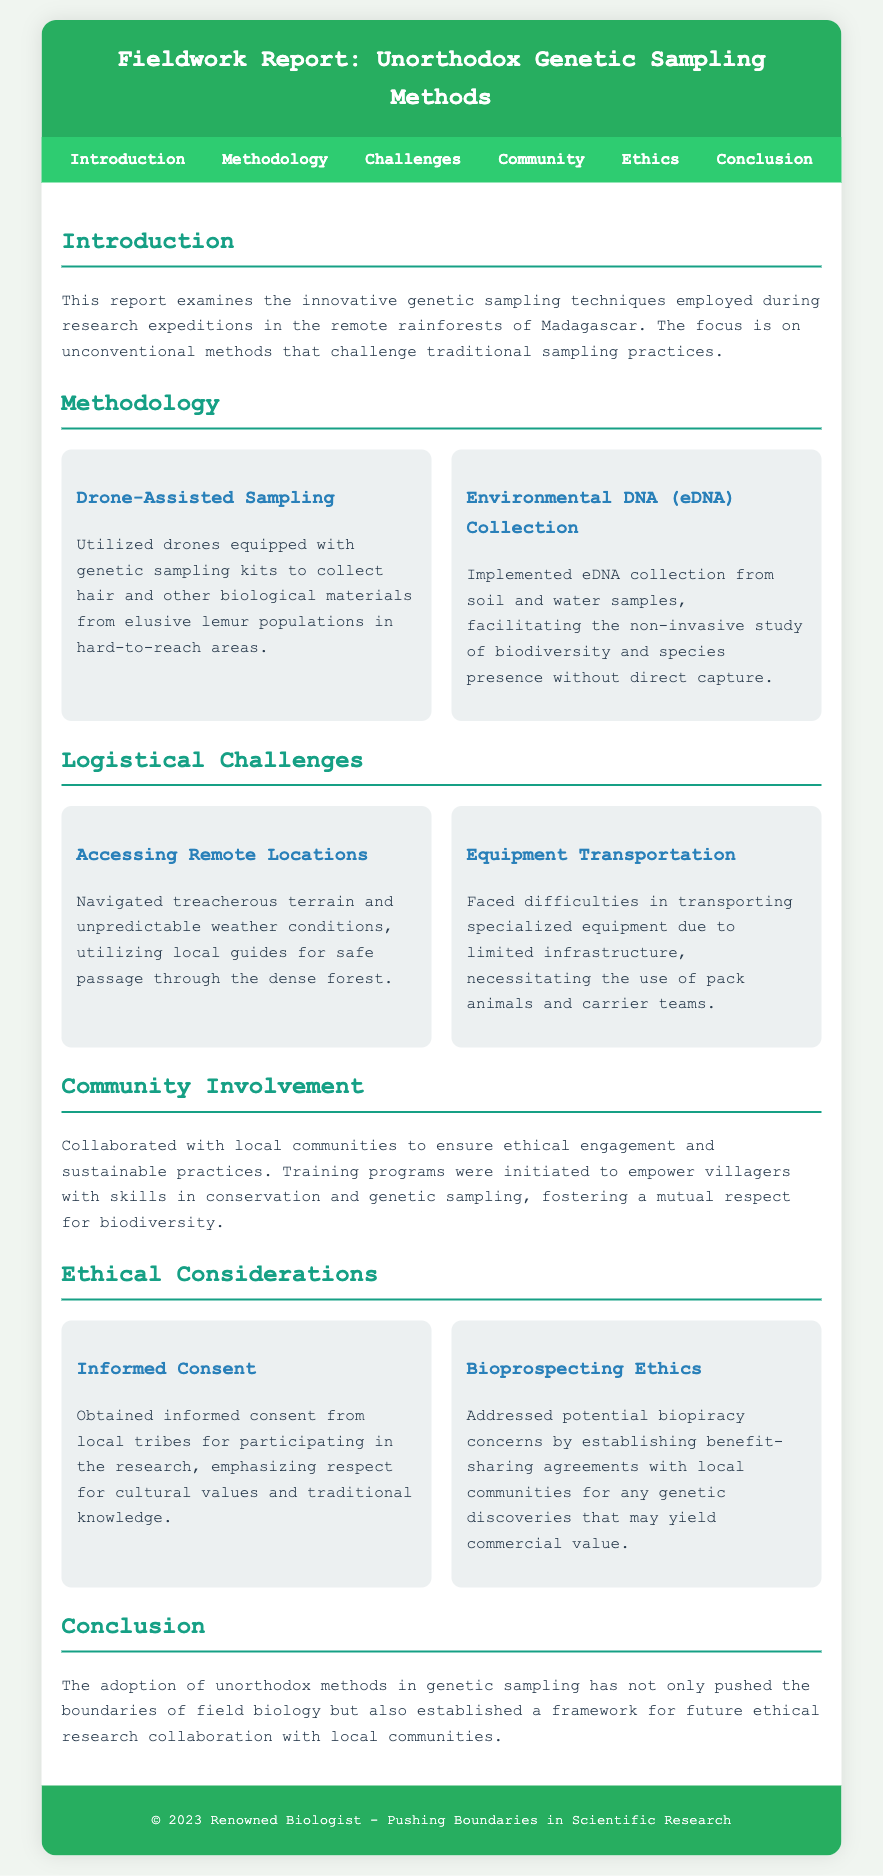What are the two primary methods highlighted in the methodology section? The methods presented in the methodology section are Drone-Assisted Sampling and Environmental DNA Collection.
Answer: Drone-Assisted Sampling, Environmental DNA Collection What logistical challenge involved terrain and weather? The challenge described in the report specifically focuses on the difficulty of accessing remote locations due to treacherous terrain and unpredictable weather conditions.
Answer: Accessing Remote Locations How were local communities engaged in the research? The document states that local communities were collaborated with to ensure ethical engagement and sustainable practices.
Answer: Collaborated with local communities What is a key ethical consideration mentioned in the report? Informed consent from local tribes is explicitly noted as an ethical consideration necessary for participation in the research.
Answer: Informed Consent How many unique sampling methods are discussed in the document? There are two unique sampling methods described in the methodology section of the report.
Answer: Two What equipment logistics challenge is specified? An equipment logistics challenge mentioned involves the difficulties in transporting specialized equipment due to limited infrastructure.
Answer: Equipment Transportation What benefit-sharing agreement concern is addressed? The document mentions addressing biopiracy concerns through establishing benefit-sharing agreements for genetic discoveries.
Answer: Bioprospecting Ethics What was a goal for training programs initiated in the community? The training programs aimed to empower villagers with skills in conservation and genetic sampling.
Answer: Empower villagers with skills in conservation and genetic sampling What geographic location is the focus of the fieldwork report? The report discusses research expeditions specifically located in the remote rainforests of Madagascar.
Answer: Madagascar 